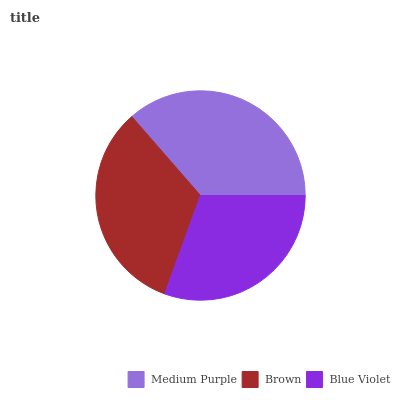Is Blue Violet the minimum?
Answer yes or no. Yes. Is Medium Purple the maximum?
Answer yes or no. Yes. Is Brown the minimum?
Answer yes or no. No. Is Brown the maximum?
Answer yes or no. No. Is Medium Purple greater than Brown?
Answer yes or no. Yes. Is Brown less than Medium Purple?
Answer yes or no. Yes. Is Brown greater than Medium Purple?
Answer yes or no. No. Is Medium Purple less than Brown?
Answer yes or no. No. Is Brown the high median?
Answer yes or no. Yes. Is Brown the low median?
Answer yes or no. Yes. Is Medium Purple the high median?
Answer yes or no. No. Is Medium Purple the low median?
Answer yes or no. No. 